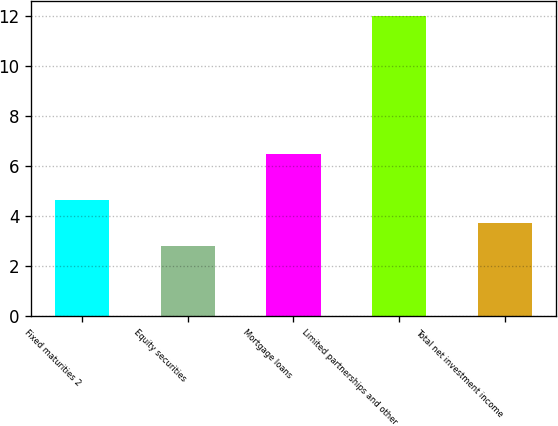Convert chart to OTSL. <chart><loc_0><loc_0><loc_500><loc_500><bar_chart><fcel>Fixed maturities 2<fcel>Equity securities<fcel>Mortgage loans<fcel>Limited partnerships and other<fcel>Total net investment income<nl><fcel>4.64<fcel>2.8<fcel>6.48<fcel>12<fcel>3.72<nl></chart> 